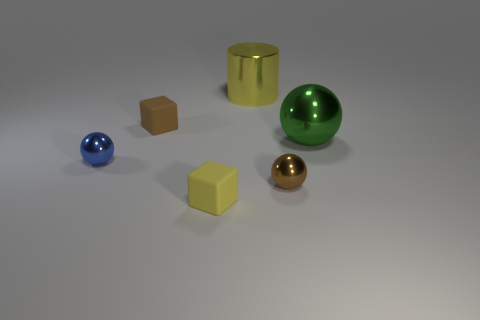Subtract all tiny metal spheres. How many spheres are left? 1 Subtract 1 blocks. How many blocks are left? 1 Add 2 purple objects. How many objects exist? 8 Subtract all blocks. How many objects are left? 4 Add 6 yellow cubes. How many yellow cubes are left? 7 Add 5 cyan matte balls. How many cyan matte balls exist? 5 Subtract 1 brown spheres. How many objects are left? 5 Subtract all red spheres. Subtract all red cylinders. How many spheres are left? 3 Subtract all tiny brown metallic things. Subtract all large yellow cylinders. How many objects are left? 4 